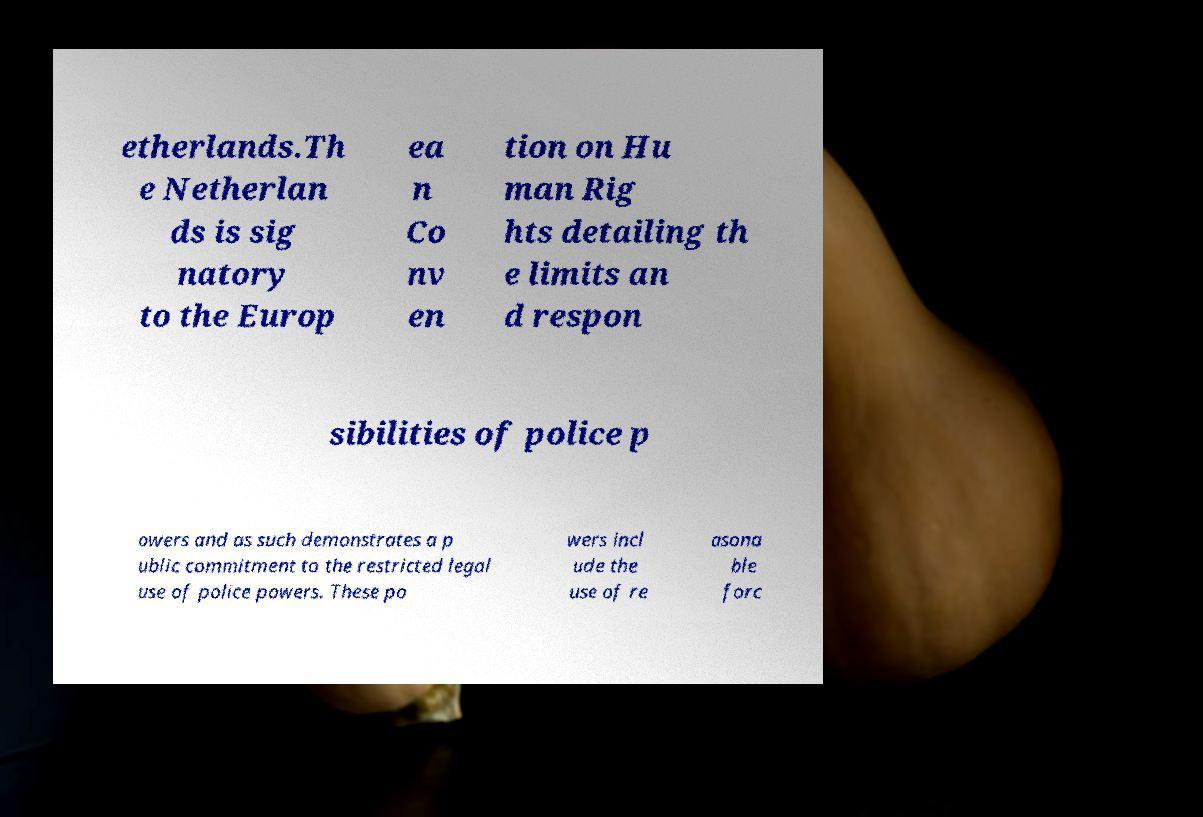Please identify and transcribe the text found in this image. etherlands.Th e Netherlan ds is sig natory to the Europ ea n Co nv en tion on Hu man Rig hts detailing th e limits an d respon sibilities of police p owers and as such demonstrates a p ublic commitment to the restricted legal use of police powers. These po wers incl ude the use of re asona ble forc 